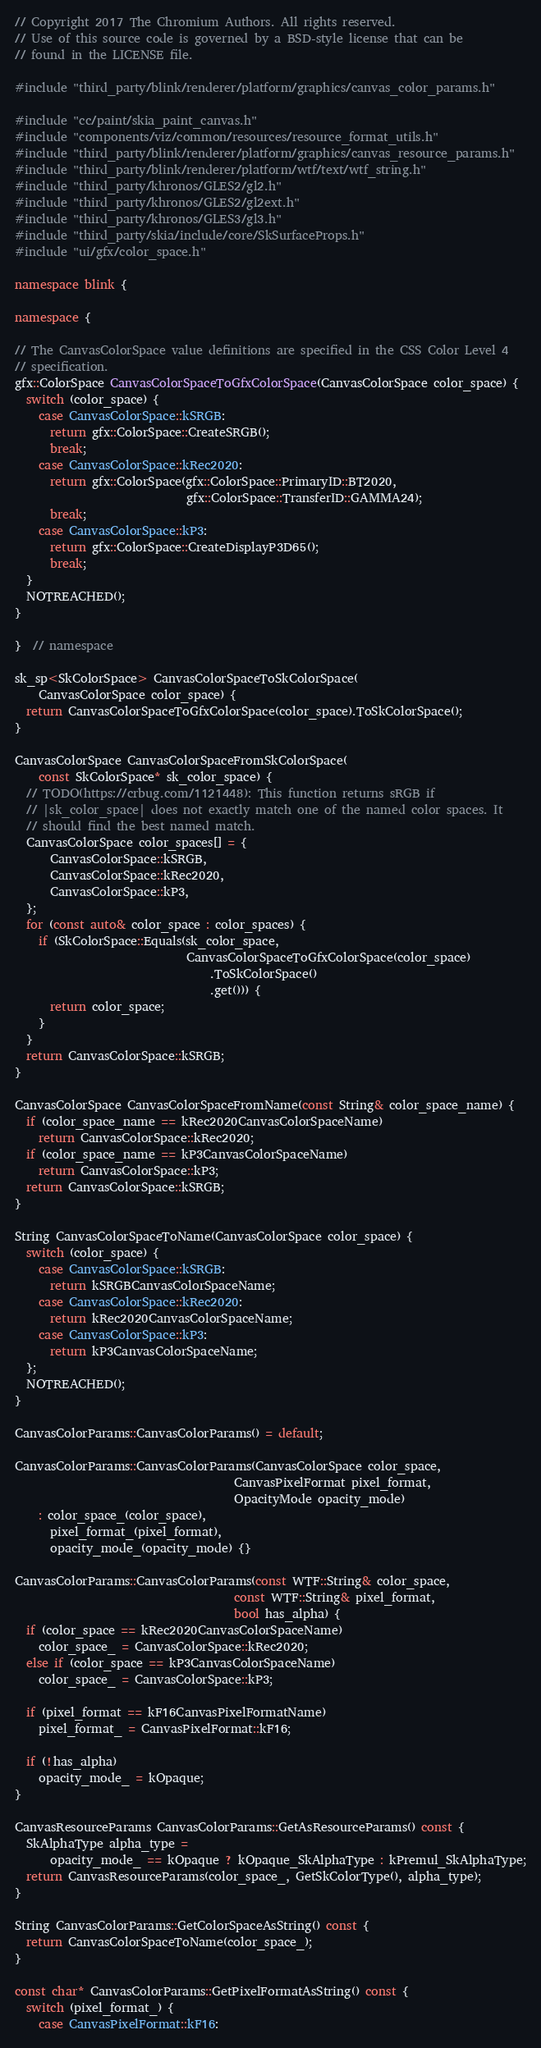<code> <loc_0><loc_0><loc_500><loc_500><_C++_>// Copyright 2017 The Chromium Authors. All rights reserved.
// Use of this source code is governed by a BSD-style license that can be
// found in the LICENSE file.

#include "third_party/blink/renderer/platform/graphics/canvas_color_params.h"

#include "cc/paint/skia_paint_canvas.h"
#include "components/viz/common/resources/resource_format_utils.h"
#include "third_party/blink/renderer/platform/graphics/canvas_resource_params.h"
#include "third_party/blink/renderer/platform/wtf/text/wtf_string.h"
#include "third_party/khronos/GLES2/gl2.h"
#include "third_party/khronos/GLES2/gl2ext.h"
#include "third_party/khronos/GLES3/gl3.h"
#include "third_party/skia/include/core/SkSurfaceProps.h"
#include "ui/gfx/color_space.h"

namespace blink {

namespace {

// The CanvasColorSpace value definitions are specified in the CSS Color Level 4
// specification.
gfx::ColorSpace CanvasColorSpaceToGfxColorSpace(CanvasColorSpace color_space) {
  switch (color_space) {
    case CanvasColorSpace::kSRGB:
      return gfx::ColorSpace::CreateSRGB();
      break;
    case CanvasColorSpace::kRec2020:
      return gfx::ColorSpace(gfx::ColorSpace::PrimaryID::BT2020,
                             gfx::ColorSpace::TransferID::GAMMA24);
      break;
    case CanvasColorSpace::kP3:
      return gfx::ColorSpace::CreateDisplayP3D65();
      break;
  }
  NOTREACHED();
}

}  // namespace

sk_sp<SkColorSpace> CanvasColorSpaceToSkColorSpace(
    CanvasColorSpace color_space) {
  return CanvasColorSpaceToGfxColorSpace(color_space).ToSkColorSpace();
}

CanvasColorSpace CanvasColorSpaceFromSkColorSpace(
    const SkColorSpace* sk_color_space) {
  // TODO(https://crbug.com/1121448): This function returns sRGB if
  // |sk_color_space| does not exactly match one of the named color spaces. It
  // should find the best named match.
  CanvasColorSpace color_spaces[] = {
      CanvasColorSpace::kSRGB,
      CanvasColorSpace::kRec2020,
      CanvasColorSpace::kP3,
  };
  for (const auto& color_space : color_spaces) {
    if (SkColorSpace::Equals(sk_color_space,
                             CanvasColorSpaceToGfxColorSpace(color_space)
                                 .ToSkColorSpace()
                                 .get())) {
      return color_space;
    }
  }
  return CanvasColorSpace::kSRGB;
}

CanvasColorSpace CanvasColorSpaceFromName(const String& color_space_name) {
  if (color_space_name == kRec2020CanvasColorSpaceName)
    return CanvasColorSpace::kRec2020;
  if (color_space_name == kP3CanvasColorSpaceName)
    return CanvasColorSpace::kP3;
  return CanvasColorSpace::kSRGB;
}

String CanvasColorSpaceToName(CanvasColorSpace color_space) {
  switch (color_space) {
    case CanvasColorSpace::kSRGB:
      return kSRGBCanvasColorSpaceName;
    case CanvasColorSpace::kRec2020:
      return kRec2020CanvasColorSpaceName;
    case CanvasColorSpace::kP3:
      return kP3CanvasColorSpaceName;
  };
  NOTREACHED();
}

CanvasColorParams::CanvasColorParams() = default;

CanvasColorParams::CanvasColorParams(CanvasColorSpace color_space,
                                     CanvasPixelFormat pixel_format,
                                     OpacityMode opacity_mode)
    : color_space_(color_space),
      pixel_format_(pixel_format),
      opacity_mode_(opacity_mode) {}

CanvasColorParams::CanvasColorParams(const WTF::String& color_space,
                                     const WTF::String& pixel_format,
                                     bool has_alpha) {
  if (color_space == kRec2020CanvasColorSpaceName)
    color_space_ = CanvasColorSpace::kRec2020;
  else if (color_space == kP3CanvasColorSpaceName)
    color_space_ = CanvasColorSpace::kP3;

  if (pixel_format == kF16CanvasPixelFormatName)
    pixel_format_ = CanvasPixelFormat::kF16;

  if (!has_alpha)
    opacity_mode_ = kOpaque;
}

CanvasResourceParams CanvasColorParams::GetAsResourceParams() const {
  SkAlphaType alpha_type =
      opacity_mode_ == kOpaque ? kOpaque_SkAlphaType : kPremul_SkAlphaType;
  return CanvasResourceParams(color_space_, GetSkColorType(), alpha_type);
}

String CanvasColorParams::GetColorSpaceAsString() const {
  return CanvasColorSpaceToName(color_space_);
}

const char* CanvasColorParams::GetPixelFormatAsString() const {
  switch (pixel_format_) {
    case CanvasPixelFormat::kF16:</code> 